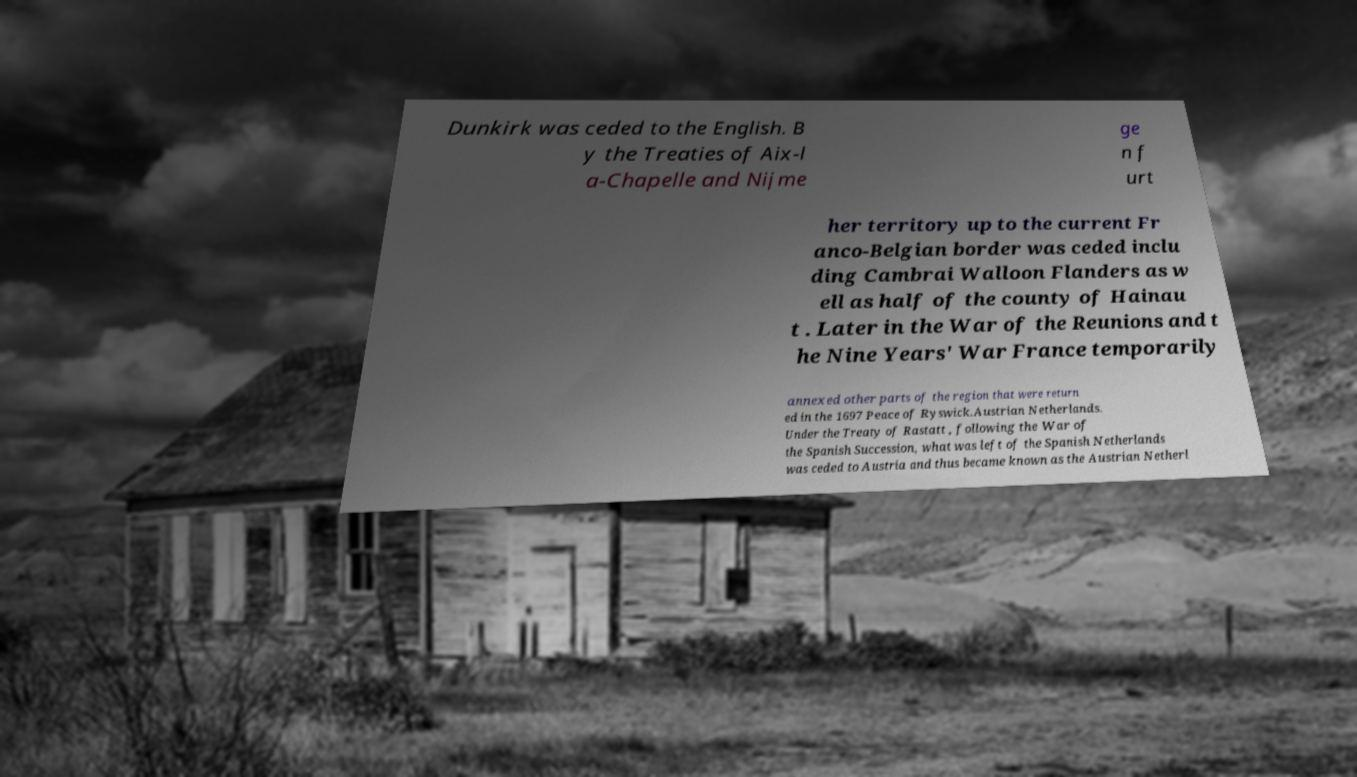Can you accurately transcribe the text from the provided image for me? Dunkirk was ceded to the English. B y the Treaties of Aix-l a-Chapelle and Nijme ge n f urt her territory up to the current Fr anco-Belgian border was ceded inclu ding Cambrai Walloon Flanders as w ell as half of the county of Hainau t . Later in the War of the Reunions and t he Nine Years' War France temporarily annexed other parts of the region that were return ed in the 1697 Peace of Ryswick.Austrian Netherlands. Under the Treaty of Rastatt , following the War of the Spanish Succession, what was left of the Spanish Netherlands was ceded to Austria and thus became known as the Austrian Netherl 